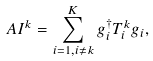<formula> <loc_0><loc_0><loc_500><loc_500>A I ^ { k } = \sum _ { i = 1 , i \neq k } ^ { K } g _ { i } ^ { \dagger } T ^ { k } _ { i } g _ { i } ,</formula> 